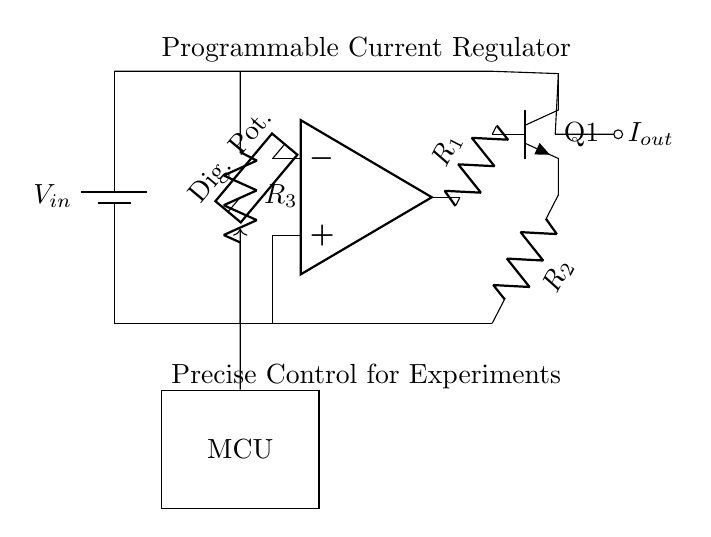What is the type of this circuit? This circuit is a programmable current regulator. It is designed to regulate current output precisely for experimental setups. The main components, including the operational amplifier, transistor, and digital potentiometer, illustrate its role in current regulation.
Answer: Programmable current regulator What component provides the input voltage? The circuit has a battery labeled as \( V_{in} \), which serves as the power supply for the entire circuit. It is the source of voltage needed for operation.
Answer: Battery Which component is used for current control? The digital potentiometer connected to the operational amplifier adjusts the feedback, impacting the current flowing through the transistor. It provides programmable control for current settings.
Answer: Digital potentiometer What is the output of this circuit? The output, indicated by \( I_{out} \), signifies the regulated current delivered by the circuit. It is taken from the collector of the transistor. This output can be adjusted based on the settings of the digital potentiometer and feedback from the operational amplifier.
Answer: \( I_{out} \) How does the operational amplifier influence current regulation? The operational amplifier compares the input voltage across its terminals and adjusts the output accordingly to maintain the desired current level. It does this by controlling the transistor's base, affecting its conduction and hence the overall current output to match the reference set by the digital potentiometer.
Answer: By controlling the transistor What is the function of resistor R1? Resistor \( R_1 \) is used to establish a feedback mechanism for the operational amplifier. It helps set the gain of the amplifier used to compare the output current with a reference value, influencing the regulation process.
Answer: Feedback How many resistors are present in the circuit? There are three resistors labeled \( R_1 \), \( R_2 \), and \( R_3 \) in the circuit. Each resistor serves a distinct purpose in the feedback and current path of the circuit, contributing to its current regulation functionality.
Answer: Three 